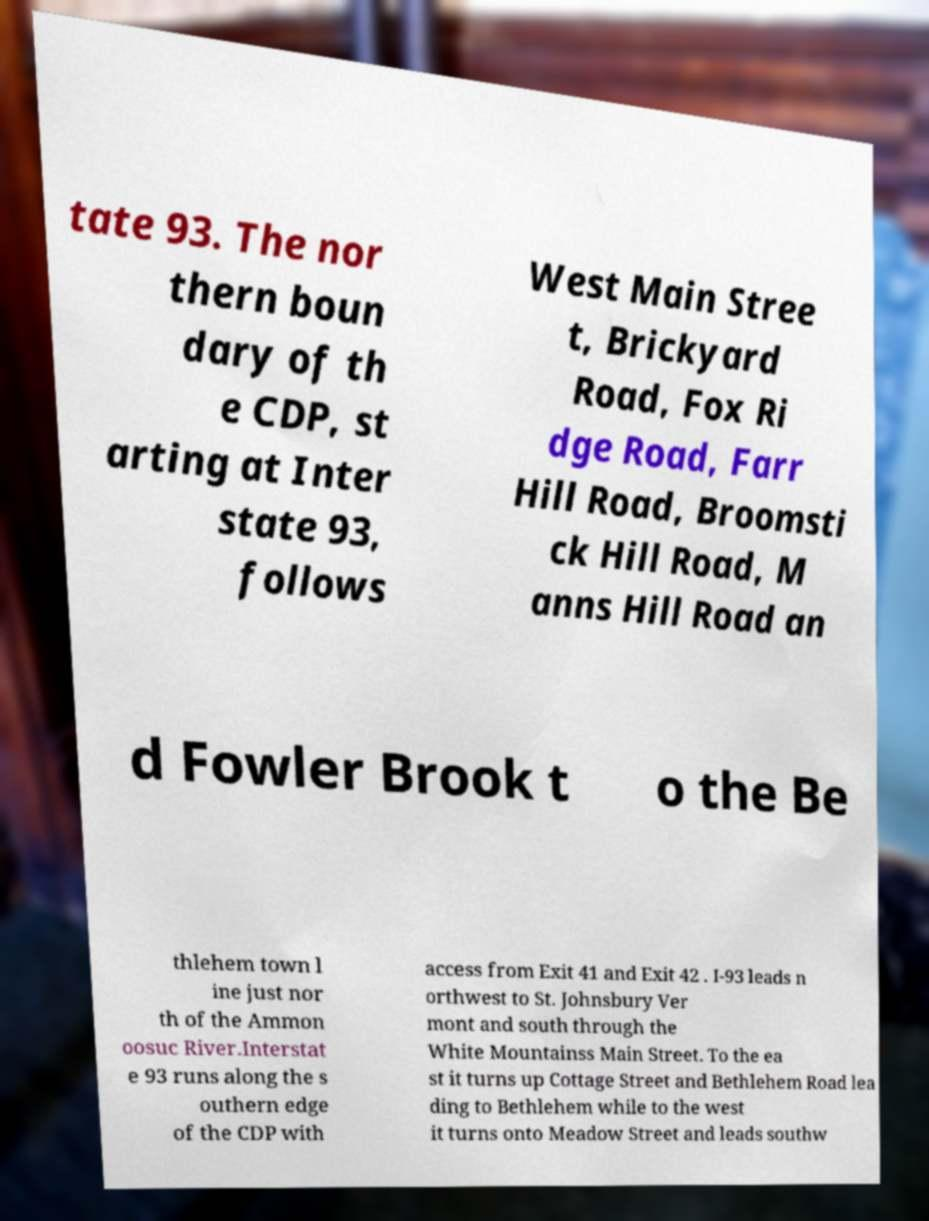Please identify and transcribe the text found in this image. tate 93. The nor thern boun dary of th e CDP, st arting at Inter state 93, follows West Main Stree t, Brickyard Road, Fox Ri dge Road, Farr Hill Road, Broomsti ck Hill Road, M anns Hill Road an d Fowler Brook t o the Be thlehem town l ine just nor th of the Ammon oosuc River.Interstat e 93 runs along the s outhern edge of the CDP with access from Exit 41 and Exit 42 . I-93 leads n orthwest to St. Johnsbury Ver mont and south through the White Mountainss Main Street. To the ea st it turns up Cottage Street and Bethlehem Road lea ding to Bethlehem while to the west it turns onto Meadow Street and leads southw 